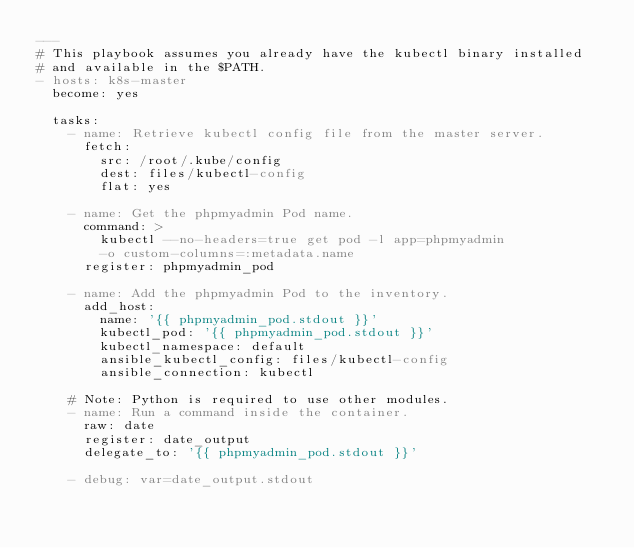Convert code to text. <code><loc_0><loc_0><loc_500><loc_500><_YAML_>---
# This playbook assumes you already have the kubectl binary installed
# and available in the $PATH.
- hosts: k8s-master
  become: yes

  tasks:
    - name: Retrieve kubectl config file from the master server.
      fetch:
        src: /root/.kube/config
        dest: files/kubectl-config
        flat: yes

    - name: Get the phpmyadmin Pod name.
      command: >
        kubectl --no-headers=true get pod -l app=phpmyadmin
        -o custom-columns=:metadata.name
      register: phpmyadmin_pod

    - name: Add the phpmyadmin Pod to the inventory.
      add_host:
        name: '{{ phpmyadmin_pod.stdout }}'
        kubectl_pod: '{{ phpmyadmin_pod.stdout }}'
        kubectl_namespace: default
        ansible_kubectl_config: files/kubectl-config
        ansible_connection: kubectl

    # Note: Python is required to use other modules.
    - name: Run a command inside the container.
      raw: date
      register: date_output
      delegate_to: '{{ phpmyadmin_pod.stdout }}'

    - debug: var=date_output.stdout
</code> 